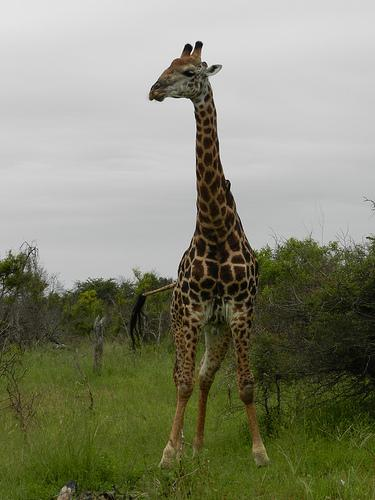Question: what is the weather?
Choices:
A. Cloudy.
B. Sunny.
C. Rainy.
D. Stormy.
Answer with the letter. Answer: A Question: where is the giraffe standing?
Choices:
A. Under the shelter.
B. Under the tree.
C. In the shade.
D. In the grass.
Answer with the letter. Answer: D Question: what color is the end of the giraffe's tail?
Choices:
A. Brown.
B. Green.
C. Black.
D. Grey.
Answer with the letter. Answer: C Question: how many giraffes are pictured?
Choices:
A. Two.
B. Three.
C. Four.
D. One.
Answer with the letter. Answer: D Question: what is the giraffe doing?
Choices:
A. Waiting.
B. Running.
C. Standing.
D. Walking.
Answer with the letter. Answer: C Question: what animal is pictured?
Choices:
A. A bird.
B. A butterfly.
C. A giraffe.
D. A dog.
Answer with the letter. Answer: C Question: how many legs does the giraffe have?
Choices:
A. Three.
B. Two.
C. Four.
D. Five.
Answer with the letter. Answer: C 